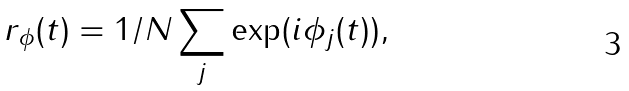<formula> <loc_0><loc_0><loc_500><loc_500>r _ { \phi } ( t ) = 1 / N \sum _ { j } \exp ( i \phi _ { j } ( t ) ) ,</formula> 